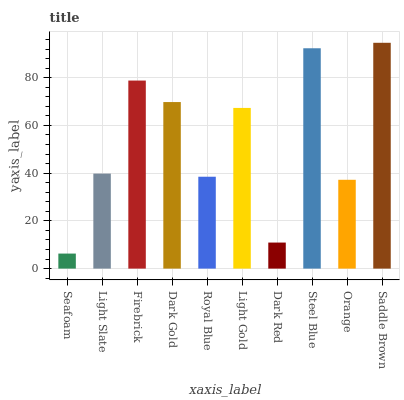Is Seafoam the minimum?
Answer yes or no. Yes. Is Saddle Brown the maximum?
Answer yes or no. Yes. Is Light Slate the minimum?
Answer yes or no. No. Is Light Slate the maximum?
Answer yes or no. No. Is Light Slate greater than Seafoam?
Answer yes or no. Yes. Is Seafoam less than Light Slate?
Answer yes or no. Yes. Is Seafoam greater than Light Slate?
Answer yes or no. No. Is Light Slate less than Seafoam?
Answer yes or no. No. Is Light Gold the high median?
Answer yes or no. Yes. Is Light Slate the low median?
Answer yes or no. Yes. Is Orange the high median?
Answer yes or no. No. Is Orange the low median?
Answer yes or no. No. 